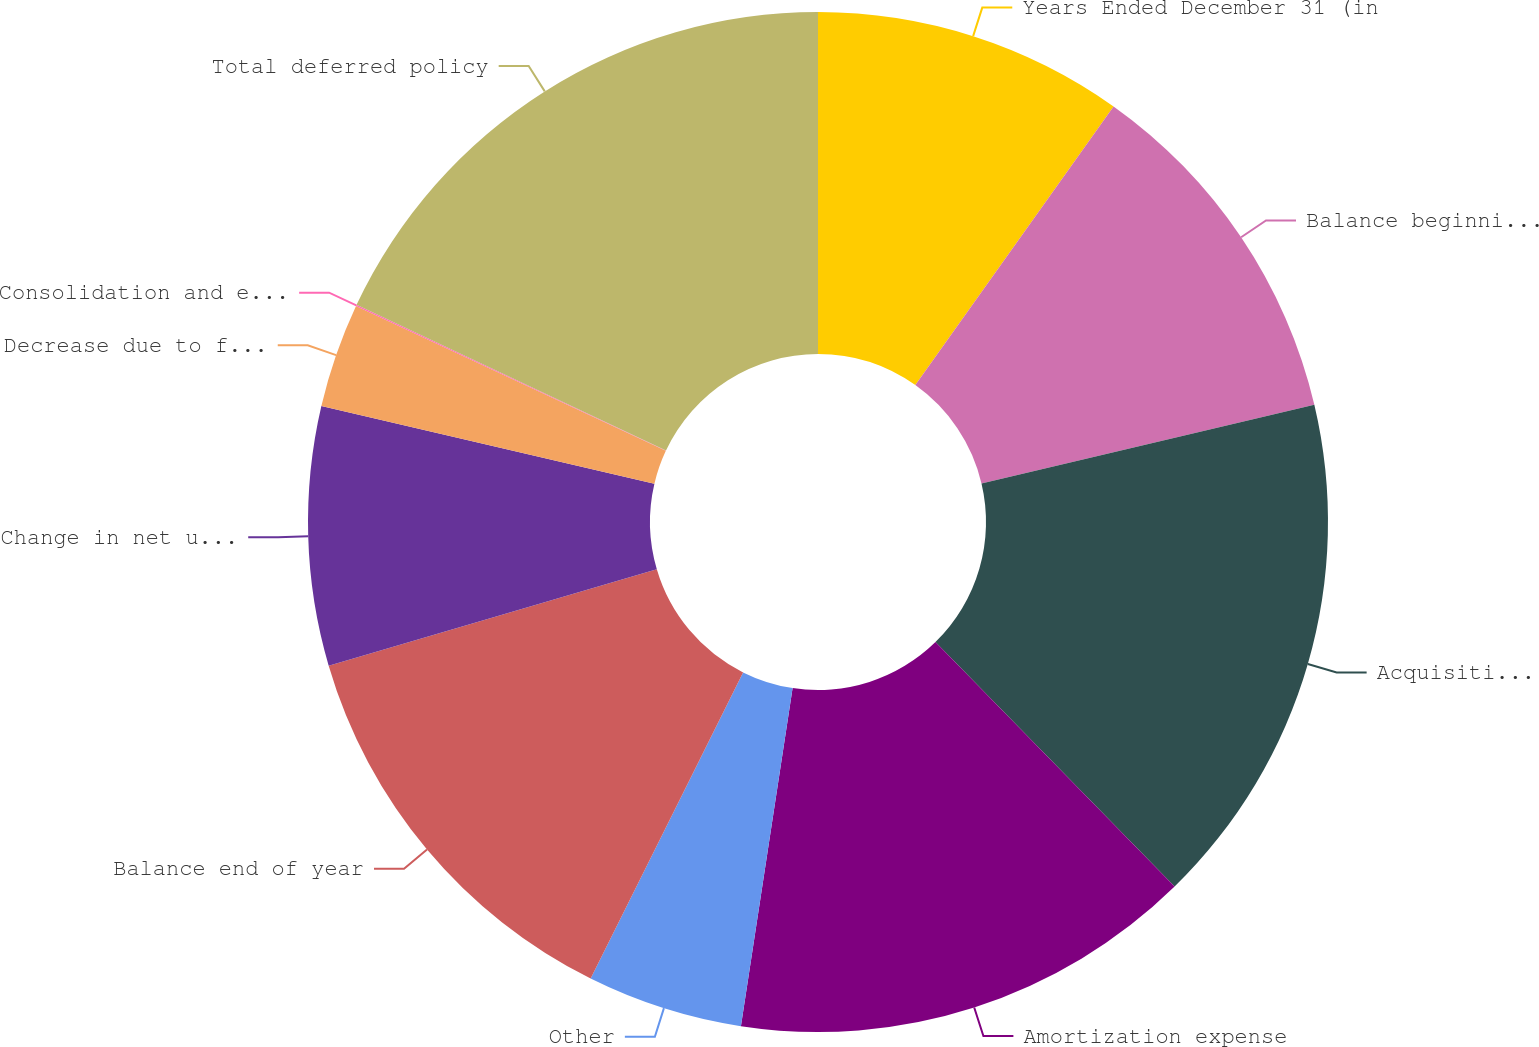Convert chart to OTSL. <chart><loc_0><loc_0><loc_500><loc_500><pie_chart><fcel>Years Ended December 31 (in<fcel>Balance beginning of year<fcel>Acquisition costs deferred<fcel>Amortization expense<fcel>Other<fcel>Balance end of year<fcel>Change in net unrealized gains<fcel>Decrease due to foreign<fcel>Consolidation and eliminations<fcel>Total deferred policy<nl><fcel>9.84%<fcel>11.47%<fcel>16.37%<fcel>14.74%<fcel>4.94%<fcel>13.1%<fcel>8.2%<fcel>3.31%<fcel>0.04%<fcel>18.0%<nl></chart> 